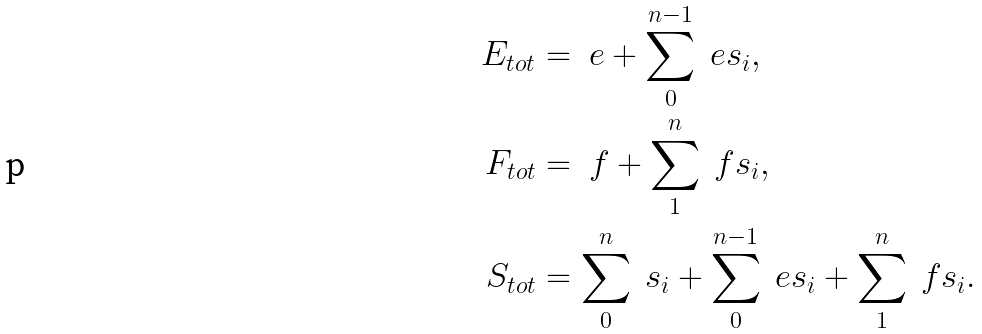<formula> <loc_0><loc_0><loc_500><loc_500>E _ { t o t } & = \ e + \sum _ { 0 } ^ { n - 1 } \ e s _ { i } , \\ F _ { t o t } & = \ f + \sum _ { 1 } ^ { n } \ f s _ { i } , \\ S _ { t o t } & = \sum _ { 0 } ^ { n } \ s _ { i } + \sum _ { 0 } ^ { n - 1 } \ e s _ { i } + \sum _ { 1 } ^ { n } \ f s _ { i } .</formula> 